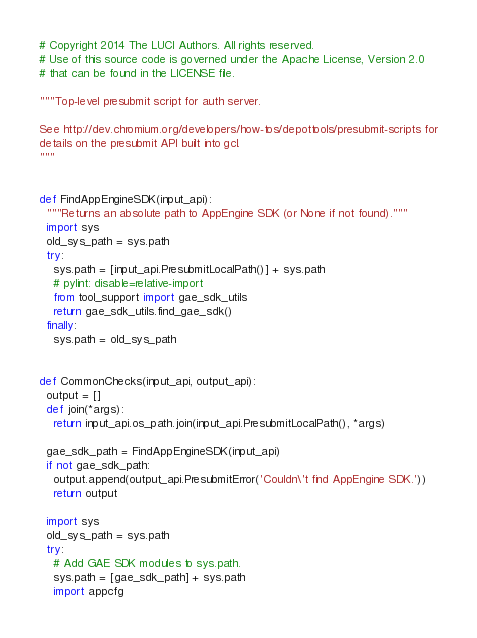<code> <loc_0><loc_0><loc_500><loc_500><_Python_># Copyright 2014 The LUCI Authors. All rights reserved.
# Use of this source code is governed under the Apache License, Version 2.0
# that can be found in the LICENSE file.

"""Top-level presubmit script for auth server.

See http://dev.chromium.org/developers/how-tos/depottools/presubmit-scripts for
details on the presubmit API built into gcl.
"""


def FindAppEngineSDK(input_api):
  """Returns an absolute path to AppEngine SDK (or None if not found)."""
  import sys
  old_sys_path = sys.path
  try:
    sys.path = [input_api.PresubmitLocalPath()] + sys.path
    # pylint: disable=relative-import
    from tool_support import gae_sdk_utils
    return gae_sdk_utils.find_gae_sdk()
  finally:
    sys.path = old_sys_path


def CommonChecks(input_api, output_api):
  output = []
  def join(*args):
    return input_api.os_path.join(input_api.PresubmitLocalPath(), *args)

  gae_sdk_path = FindAppEngineSDK(input_api)
  if not gae_sdk_path:
    output.append(output_api.PresubmitError('Couldn\'t find AppEngine SDK.'))
    return output

  import sys
  old_sys_path = sys.path
  try:
    # Add GAE SDK modules to sys.path.
    sys.path = [gae_sdk_path] + sys.path
    import appcfg</code> 